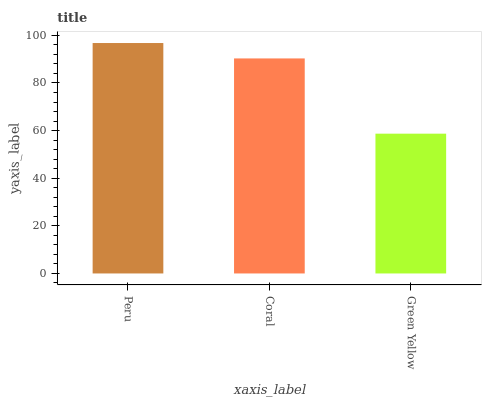Is Green Yellow the minimum?
Answer yes or no. Yes. Is Peru the maximum?
Answer yes or no. Yes. Is Coral the minimum?
Answer yes or no. No. Is Coral the maximum?
Answer yes or no. No. Is Peru greater than Coral?
Answer yes or no. Yes. Is Coral less than Peru?
Answer yes or no. Yes. Is Coral greater than Peru?
Answer yes or no. No. Is Peru less than Coral?
Answer yes or no. No. Is Coral the high median?
Answer yes or no. Yes. Is Coral the low median?
Answer yes or no. Yes. Is Peru the high median?
Answer yes or no. No. Is Peru the low median?
Answer yes or no. No. 